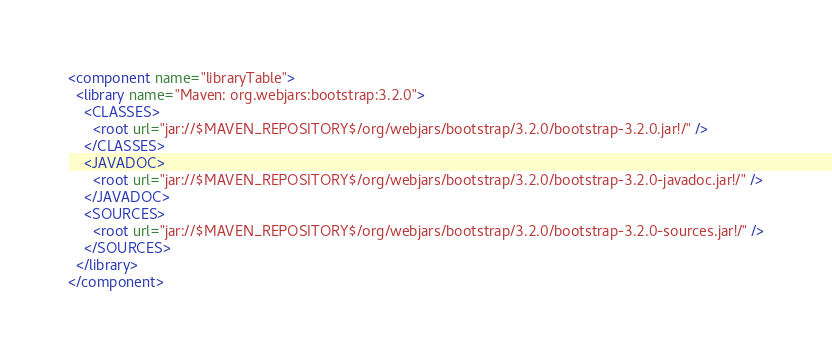Convert code to text. <code><loc_0><loc_0><loc_500><loc_500><_XML_><component name="libraryTable">
  <library name="Maven: org.webjars:bootstrap:3.2.0">
    <CLASSES>
      <root url="jar://$MAVEN_REPOSITORY$/org/webjars/bootstrap/3.2.0/bootstrap-3.2.0.jar!/" />
    </CLASSES>
    <JAVADOC>
      <root url="jar://$MAVEN_REPOSITORY$/org/webjars/bootstrap/3.2.0/bootstrap-3.2.0-javadoc.jar!/" />
    </JAVADOC>
    <SOURCES>
      <root url="jar://$MAVEN_REPOSITORY$/org/webjars/bootstrap/3.2.0/bootstrap-3.2.0-sources.jar!/" />
    </SOURCES>
  </library>
</component></code> 